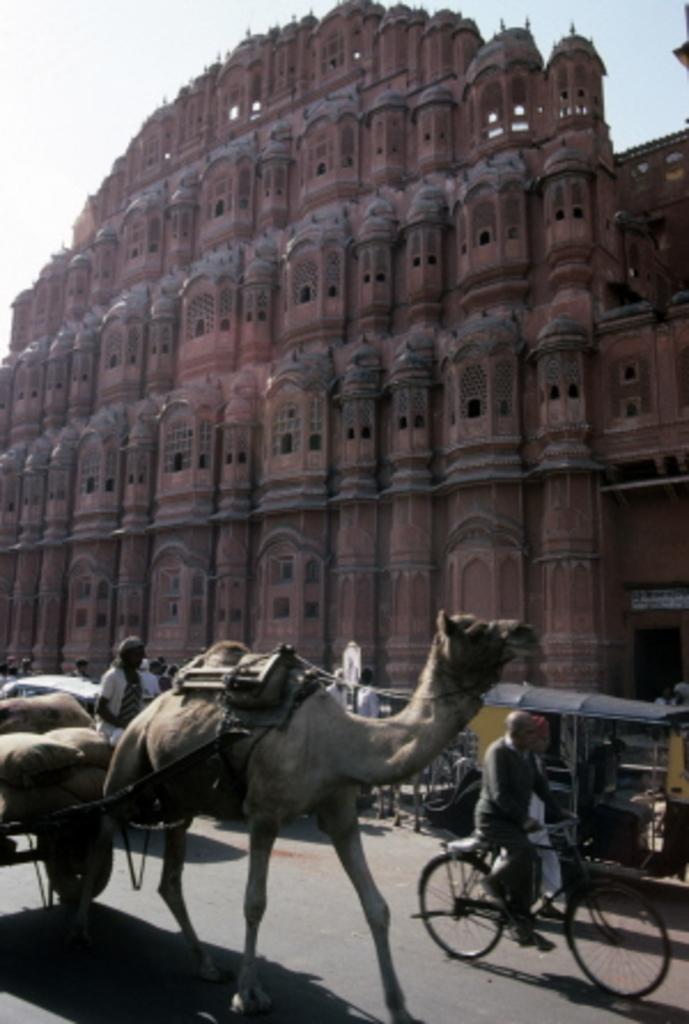How would you summarize this image in a sentence or two? In this image, There is a camel carrying a object which is in brown color, In the right side there is a man riding a bicycle and there is a auto which is in yellow and black color, In the background there is a building which is in brown color and there is sky in white color. 